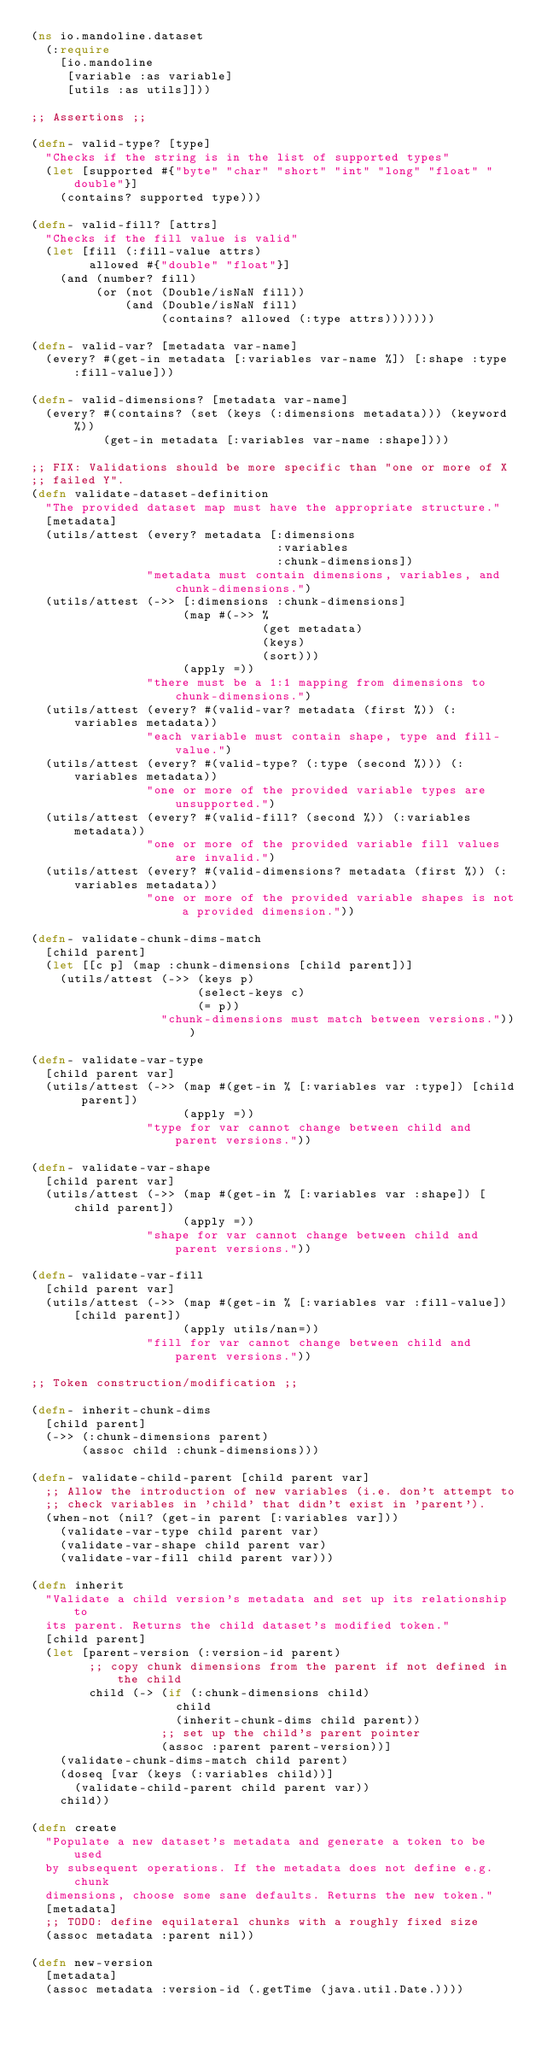<code> <loc_0><loc_0><loc_500><loc_500><_Clojure_>(ns io.mandoline.dataset
  (:require
    [io.mandoline
     [variable :as variable]
     [utils :as utils]]))

;; Assertions ;;

(defn- valid-type? [type]
  "Checks if the string is in the list of supported types"
  (let [supported #{"byte" "char" "short" "int" "long" "float" "double"}]
    (contains? supported type)))

(defn- valid-fill? [attrs]
  "Checks if the fill value is valid"
  (let [fill (:fill-value attrs)
        allowed #{"double" "float"}]
    (and (number? fill)
         (or (not (Double/isNaN fill))
             (and (Double/isNaN fill)
                  (contains? allowed (:type attrs)))))))

(defn- valid-var? [metadata var-name]
  (every? #(get-in metadata [:variables var-name %]) [:shape :type :fill-value]))

(defn- valid-dimensions? [metadata var-name]
  (every? #(contains? (set (keys (:dimensions metadata))) (keyword %))
          (get-in metadata [:variables var-name :shape])))

;; FIX: Validations should be more specific than "one or more of X
;; failed Y".
(defn validate-dataset-definition
  "The provided dataset map must have the appropriate structure."
  [metadata]
  (utils/attest (every? metadata [:dimensions
                                  :variables
                                  :chunk-dimensions])
                "metadata must contain dimensions, variables, and chunk-dimensions.")
  (utils/attest (->> [:dimensions :chunk-dimensions]
                     (map #(->> %
                                (get metadata)
                                (keys)
                                (sort)))
                     (apply =))
                "there must be a 1:1 mapping from dimensions to chunk-dimensions.")
  (utils/attest (every? #(valid-var? metadata (first %)) (:variables metadata))
                "each variable must contain shape, type and fill-value.")
  (utils/attest (every? #(valid-type? (:type (second %))) (:variables metadata))
                "one or more of the provided variable types are unsupported.")
  (utils/attest (every? #(valid-fill? (second %)) (:variables metadata))
                "one or more of the provided variable fill values are invalid.")
  (utils/attest (every? #(valid-dimensions? metadata (first %)) (:variables metadata))
                "one or more of the provided variable shapes is not a provided dimension."))

(defn- validate-chunk-dims-match
  [child parent]
  (let [[c p] (map :chunk-dimensions [child parent])]
    (utils/attest (->> (keys p)
                       (select-keys c)
                       (= p))
                  "chunk-dimensions must match between versions.")))

(defn- validate-var-type
  [child parent var]
  (utils/attest (->> (map #(get-in % [:variables var :type]) [child parent])
                     (apply =))
                "type for var cannot change between child and parent versions."))

(defn- validate-var-shape
  [child parent var]
  (utils/attest (->> (map #(get-in % [:variables var :shape]) [child parent])
                     (apply =))
                "shape for var cannot change between child and parent versions."))

(defn- validate-var-fill
  [child parent var]
  (utils/attest (->> (map #(get-in % [:variables var :fill-value]) [child parent])
                     (apply utils/nan=))
                "fill for var cannot change between child and parent versions."))

;; Token construction/modification ;;

(defn- inherit-chunk-dims
  [child parent]
  (->> (:chunk-dimensions parent)
       (assoc child :chunk-dimensions)))

(defn- validate-child-parent [child parent var]
  ;; Allow the introduction of new variables (i.e. don't attempt to
  ;; check variables in 'child' that didn't exist in 'parent').
  (when-not (nil? (get-in parent [:variables var]))
    (validate-var-type child parent var)
    (validate-var-shape child parent var)
    (validate-var-fill child parent var)))

(defn inherit
  "Validate a child version's metadata and set up its relationship to
  its parent. Returns the child dataset's modified token."
  [child parent]
  (let [parent-version (:version-id parent)
        ;; copy chunk dimensions from the parent if not defined in the child
        child (-> (if (:chunk-dimensions child)
                    child
                    (inherit-chunk-dims child parent))
                  ;; set up the child's parent pointer
                  (assoc :parent parent-version))]
    (validate-chunk-dims-match child parent)
    (doseq [var (keys (:variables child))]
      (validate-child-parent child parent var))
    child))

(defn create
  "Populate a new dataset's metadata and generate a token to be used
  by subsequent operations. If the metadata does not define e.g. chunk
  dimensions, choose some sane defaults. Returns the new token."
  [metadata]
  ;; TODO: define equilateral chunks with a roughly fixed size
  (assoc metadata :parent nil))

(defn new-version
  [metadata]
  (assoc metadata :version-id (.getTime (java.util.Date.))))
</code> 